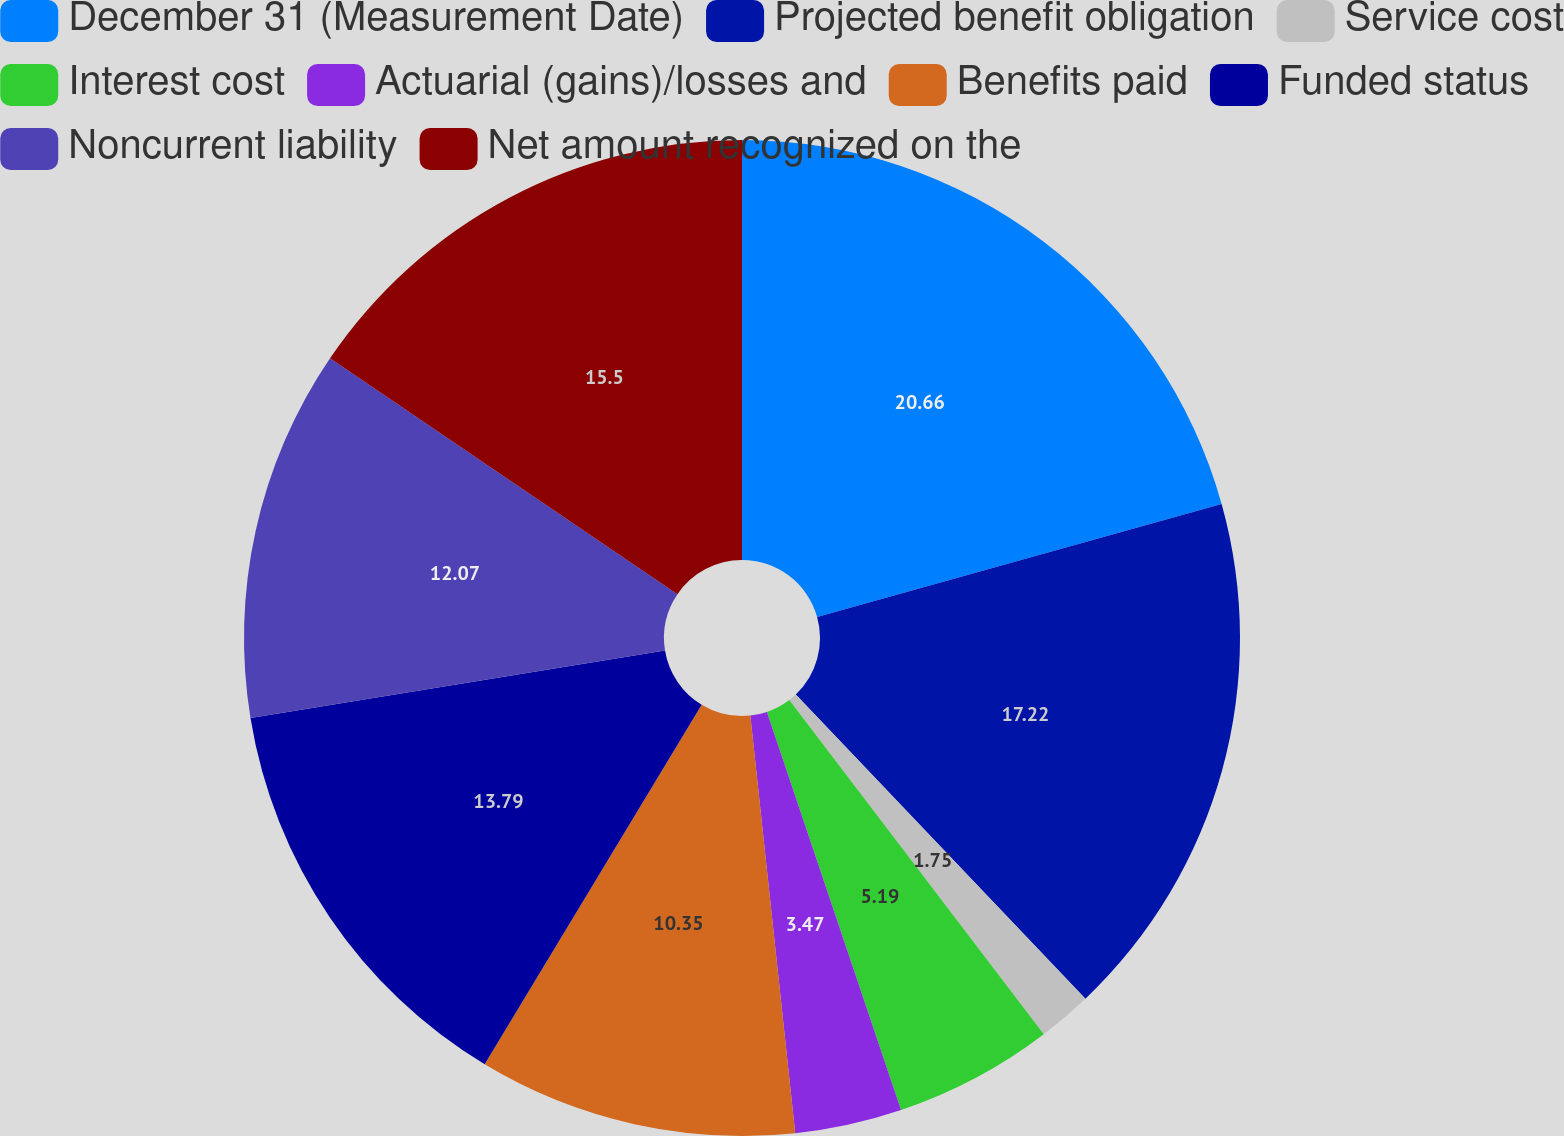Convert chart. <chart><loc_0><loc_0><loc_500><loc_500><pie_chart><fcel>December 31 (Measurement Date)<fcel>Projected benefit obligation<fcel>Service cost<fcel>Interest cost<fcel>Actuarial (gains)/losses and<fcel>Benefits paid<fcel>Funded status<fcel>Noncurrent liability<fcel>Net amount recognized on the<nl><fcel>20.67%<fcel>17.23%<fcel>1.75%<fcel>5.19%<fcel>3.47%<fcel>10.35%<fcel>13.79%<fcel>12.07%<fcel>15.51%<nl></chart> 